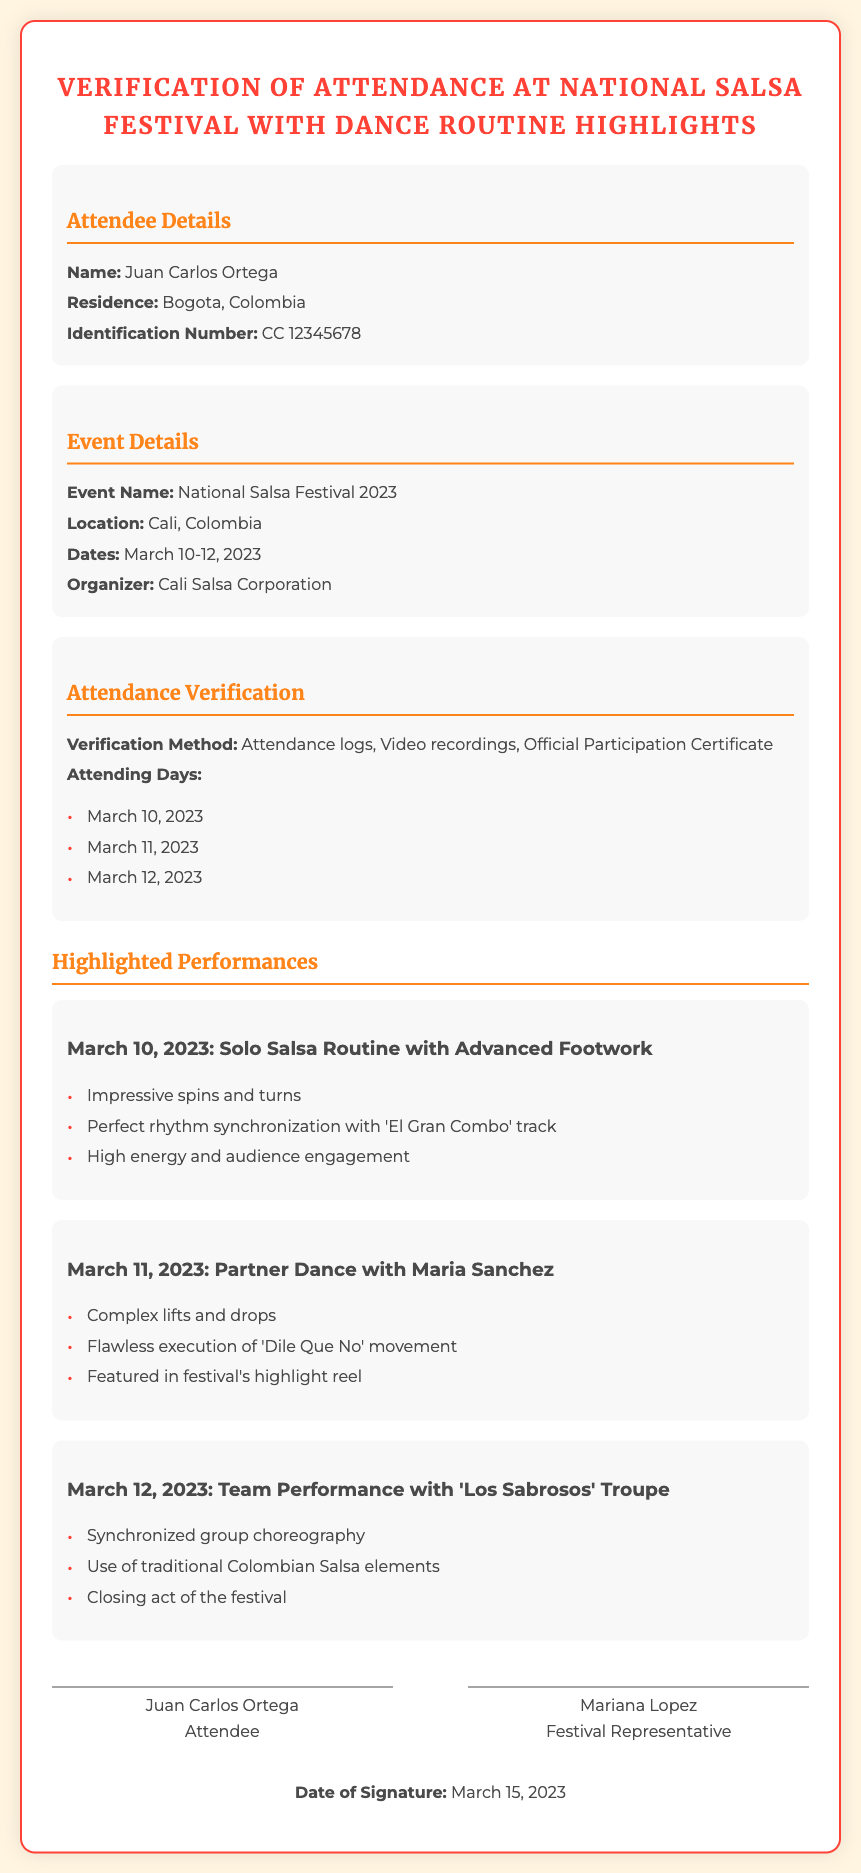What is the name of the attendee? The document lists the name of the attendee as Juan Carlos Ortega.
Answer: Juan Carlos Ortega What is the residence of the attendee? The residence mentioned in the document is Bogota, Colombia.
Answer: Bogota, Colombia What are the attending dates for the festival? The document states the attending dates are March 10-12, 2023.
Answer: March 10-12, 2023 Who organized the National Salsa Festival? According to the document, the organizer is Cali Salsa Corporation.
Answer: Cali Salsa Corporation What type of dance was performed on March 10, 2023? The document describes it as a Solo Salsa Routine with Advanced Footwork.
Answer: Solo Salsa Routine with Advanced Footwork What performance feature was highlighted on March 11, 2023? The highlighted feature was Complex lifts and drops in the partner dance.
Answer: Complex lifts and drops How was Juan Carlos Ortega verified for attendance? The verification method included attendance logs, video recordings, and an official participation certificate.
Answer: Attendance logs, video recordings, Official Participation Certificate What was the closing act of the festival? The document states that the closing act was a team performance with 'Los Sabrosos' Troupe.
Answer: Team Performance with 'Los Sabrosos' Troupe Who signed the declaration as the festival representative? Mariana Lopez is indicated as the festival representative who signed the document.
Answer: Mariana Lopez 